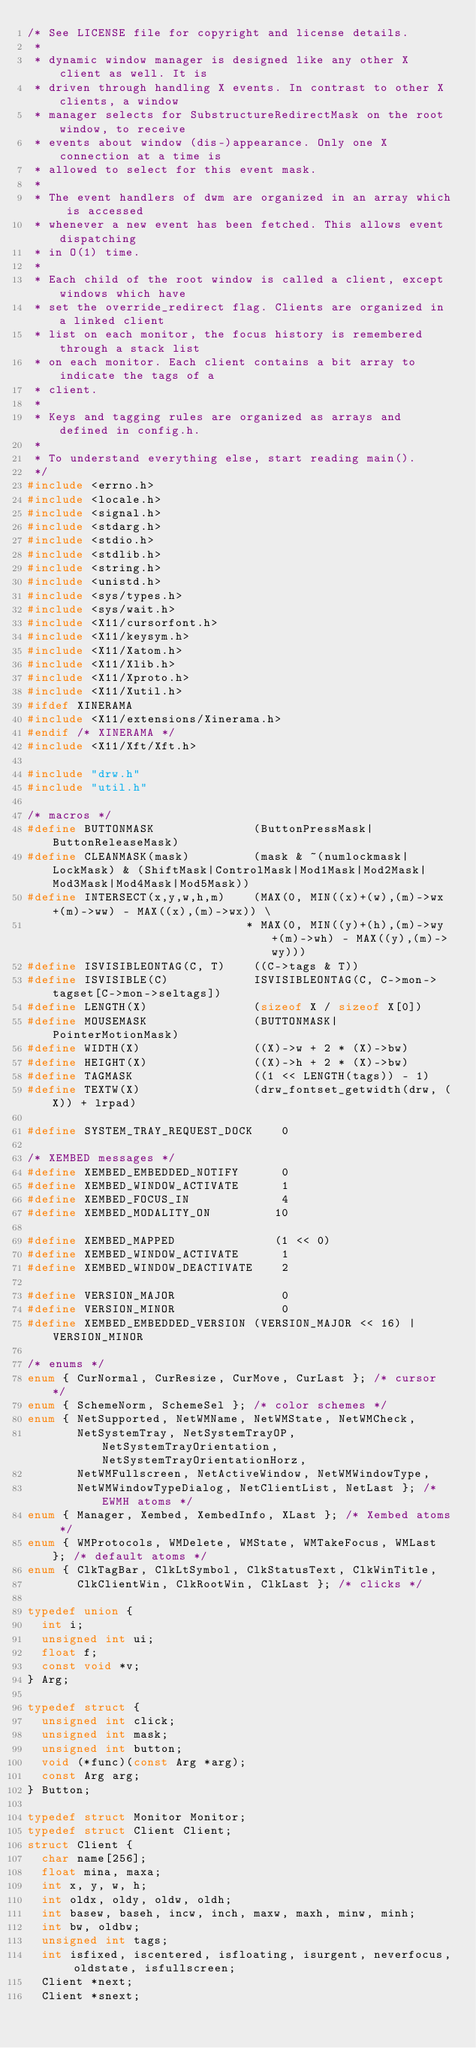<code> <loc_0><loc_0><loc_500><loc_500><_C_>/* See LICENSE file for copyright and license details.
 *
 * dynamic window manager is designed like any other X client as well. It is
 * driven through handling X events. In contrast to other X clients, a window
 * manager selects for SubstructureRedirectMask on the root window, to receive
 * events about window (dis-)appearance. Only one X connection at a time is
 * allowed to select for this event mask.
 *
 * The event handlers of dwm are organized in an array which is accessed
 * whenever a new event has been fetched. This allows event dispatching
 * in O(1) time.
 *
 * Each child of the root window is called a client, except windows which have
 * set the override_redirect flag. Clients are organized in a linked client
 * list on each monitor, the focus history is remembered through a stack list
 * on each monitor. Each client contains a bit array to indicate the tags of a
 * client.
 *
 * Keys and tagging rules are organized as arrays and defined in config.h.
 *
 * To understand everything else, start reading main().
 */
#include <errno.h>
#include <locale.h>
#include <signal.h>
#include <stdarg.h>
#include <stdio.h>
#include <stdlib.h>
#include <string.h>
#include <unistd.h>
#include <sys/types.h>
#include <sys/wait.h>
#include <X11/cursorfont.h>
#include <X11/keysym.h>
#include <X11/Xatom.h>
#include <X11/Xlib.h>
#include <X11/Xproto.h>
#include <X11/Xutil.h>
#ifdef XINERAMA
#include <X11/extensions/Xinerama.h>
#endif /* XINERAMA */
#include <X11/Xft/Xft.h>

#include "drw.h"
#include "util.h"

/* macros */
#define BUTTONMASK              (ButtonPressMask|ButtonReleaseMask)
#define CLEANMASK(mask)         (mask & ~(numlockmask|LockMask) & (ShiftMask|ControlMask|Mod1Mask|Mod2Mask|Mod3Mask|Mod4Mask|Mod5Mask))
#define INTERSECT(x,y,w,h,m)    (MAX(0, MIN((x)+(w),(m)->wx+(m)->ww) - MAX((x),(m)->wx)) \
                               * MAX(0, MIN((y)+(h),(m)->wy+(m)->wh) - MAX((y),(m)->wy)))
#define ISVISIBLEONTAG(C, T)    ((C->tags & T))
#define ISVISIBLE(C)            ISVISIBLEONTAG(C, C->mon->tagset[C->mon->seltags])
#define LENGTH(X)               (sizeof X / sizeof X[0])
#define MOUSEMASK               (BUTTONMASK|PointerMotionMask)
#define WIDTH(X)                ((X)->w + 2 * (X)->bw)
#define HEIGHT(X)               ((X)->h + 2 * (X)->bw)
#define TAGMASK                 ((1 << LENGTH(tags)) - 1)
#define TEXTW(X)                (drw_fontset_getwidth(drw, (X)) + lrpad)

#define SYSTEM_TRAY_REQUEST_DOCK    0

/* XEMBED messages */
#define XEMBED_EMBEDDED_NOTIFY      0
#define XEMBED_WINDOW_ACTIVATE      1
#define XEMBED_FOCUS_IN             4
#define XEMBED_MODALITY_ON         10

#define XEMBED_MAPPED              (1 << 0)
#define XEMBED_WINDOW_ACTIVATE      1
#define XEMBED_WINDOW_DEACTIVATE    2

#define VERSION_MAJOR               0
#define VERSION_MINOR               0
#define XEMBED_EMBEDDED_VERSION (VERSION_MAJOR << 16) | VERSION_MINOR

/* enums */
enum { CurNormal, CurResize, CurMove, CurLast }; /* cursor */
enum { SchemeNorm, SchemeSel }; /* color schemes */
enum { NetSupported, NetWMName, NetWMState, NetWMCheck,
       NetSystemTray, NetSystemTrayOP, NetSystemTrayOrientation, NetSystemTrayOrientationHorz,
       NetWMFullscreen, NetActiveWindow, NetWMWindowType,
       NetWMWindowTypeDialog, NetClientList, NetLast }; /* EWMH atoms */
enum { Manager, Xembed, XembedInfo, XLast }; /* Xembed atoms */
enum { WMProtocols, WMDelete, WMState, WMTakeFocus, WMLast }; /* default atoms */
enum { ClkTagBar, ClkLtSymbol, ClkStatusText, ClkWinTitle,
       ClkClientWin, ClkRootWin, ClkLast }; /* clicks */

typedef union {
	int i;
	unsigned int ui;
	float f;
	const void *v;
} Arg;

typedef struct {
	unsigned int click;
	unsigned int mask;
	unsigned int button;
	void (*func)(const Arg *arg);
	const Arg arg;
} Button;

typedef struct Monitor Monitor;
typedef struct Client Client;
struct Client {
	char name[256];
	float mina, maxa;
	int x, y, w, h;
	int oldx, oldy, oldw, oldh;
	int basew, baseh, incw, inch, maxw, maxh, minw, minh;
	int bw, oldbw;
	unsigned int tags;
	int isfixed, iscentered, isfloating, isurgent, neverfocus, oldstate, isfullscreen;
	Client *next;
	Client *snext;</code> 